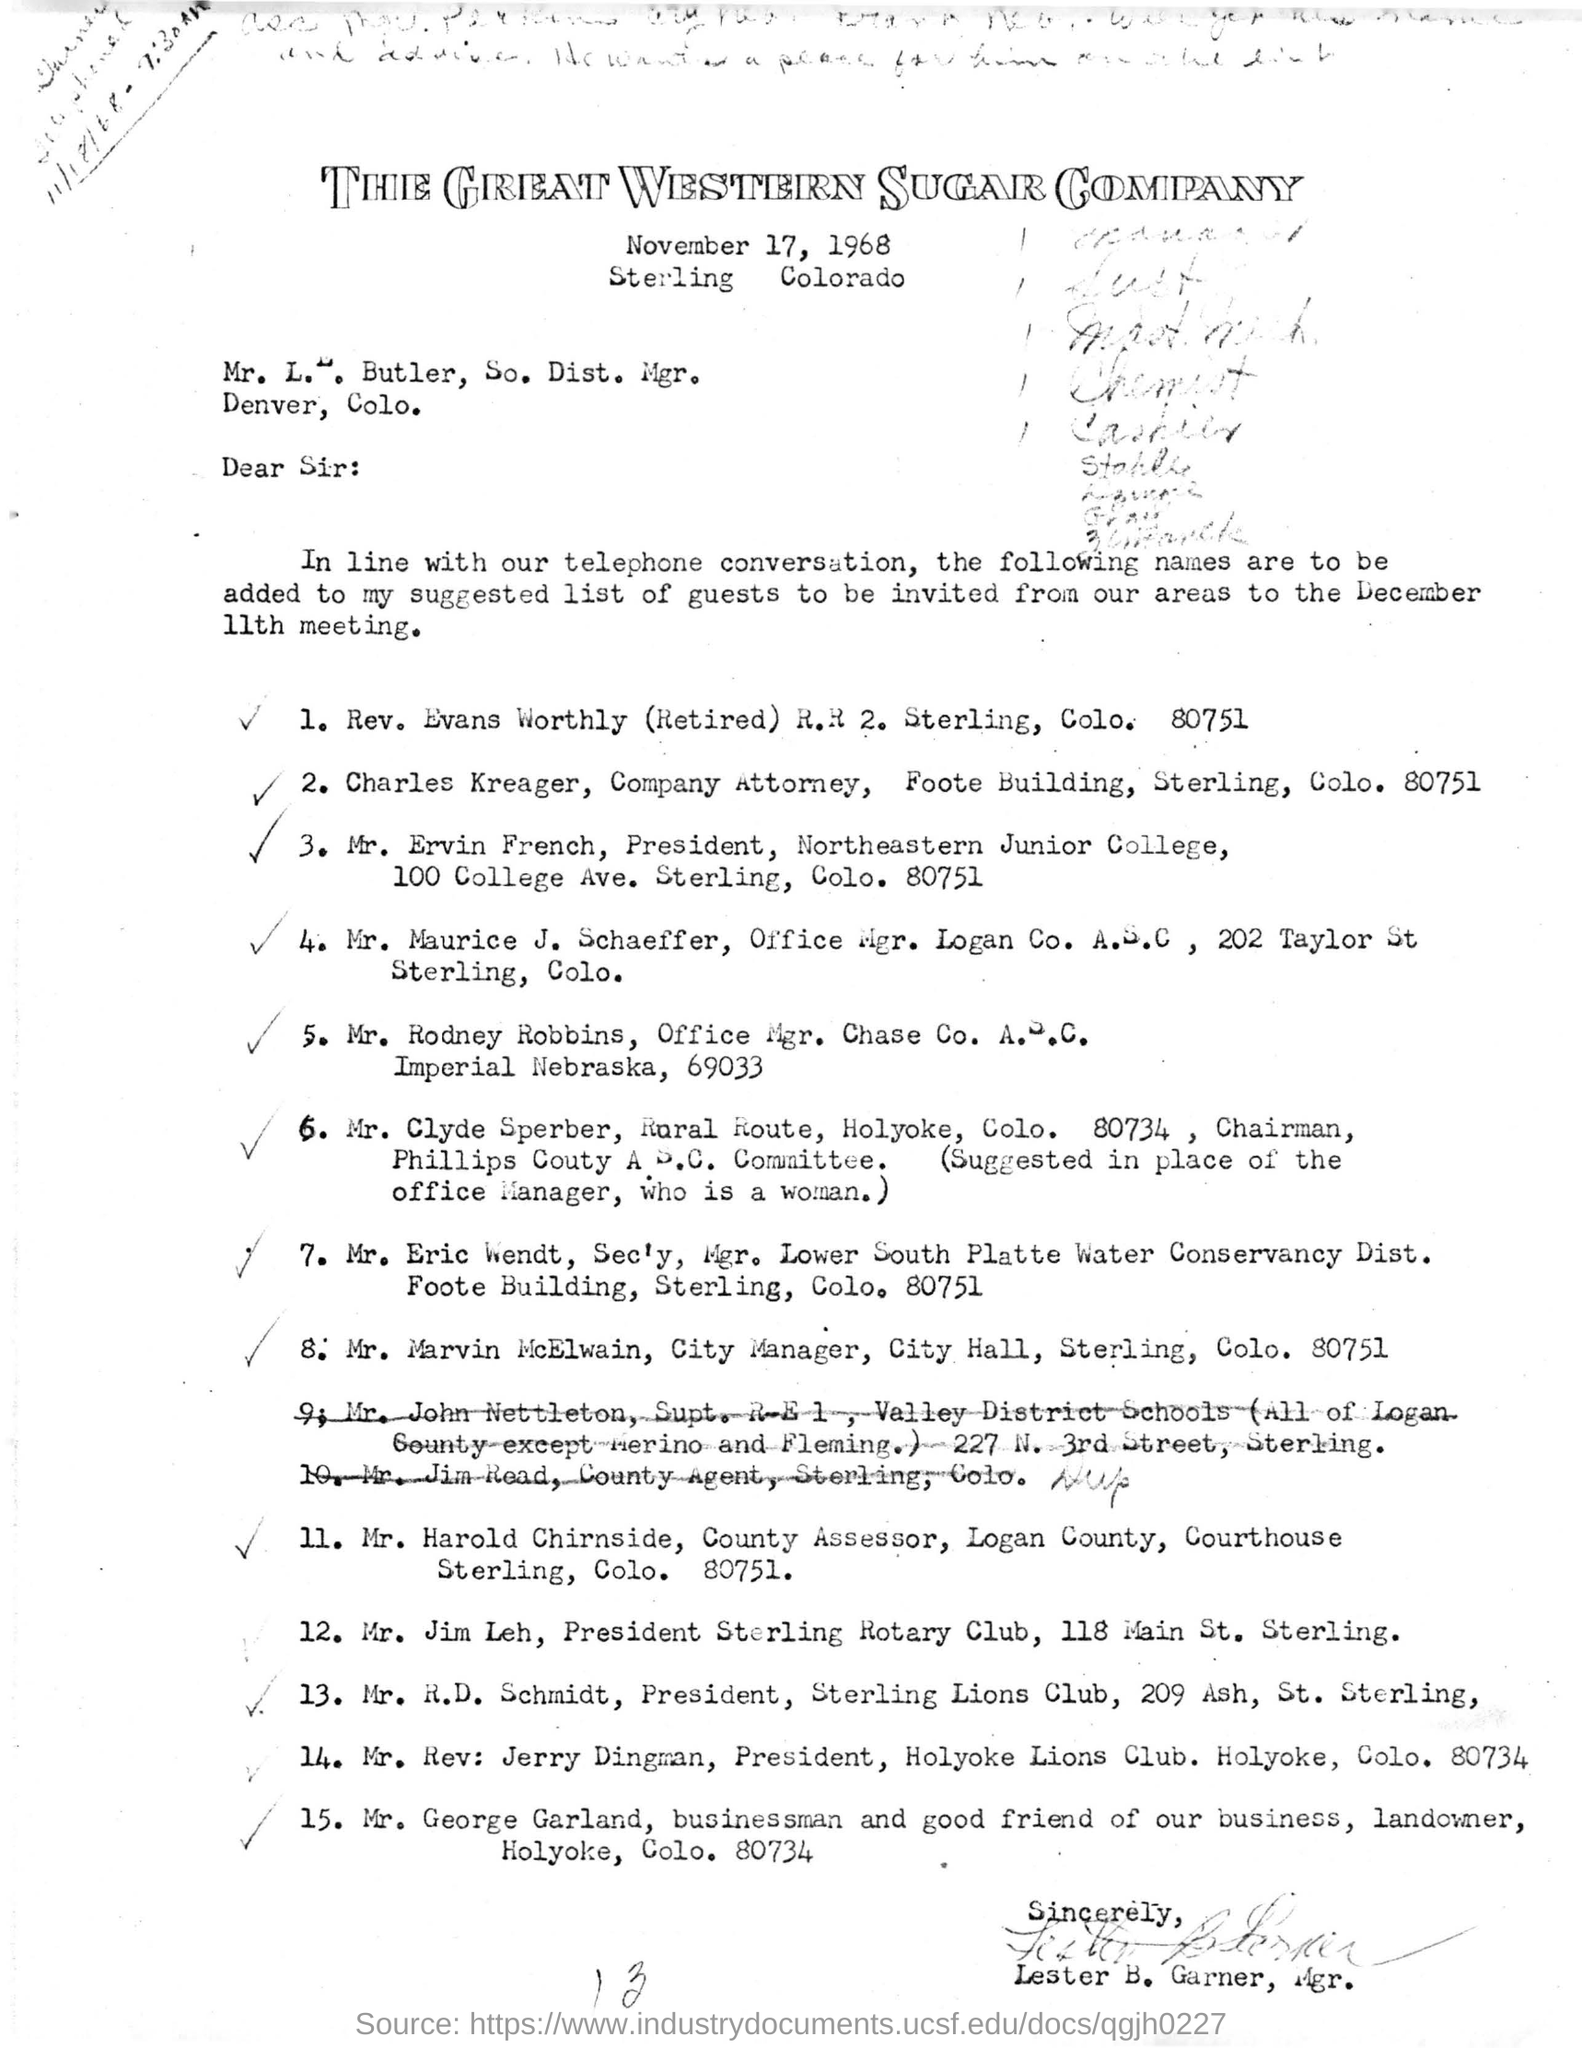Outline some significant characteristics in this image. The name of the company attorney is Charles Kreager. The president of Northeastern Junior College is Mr. Ervin French. 